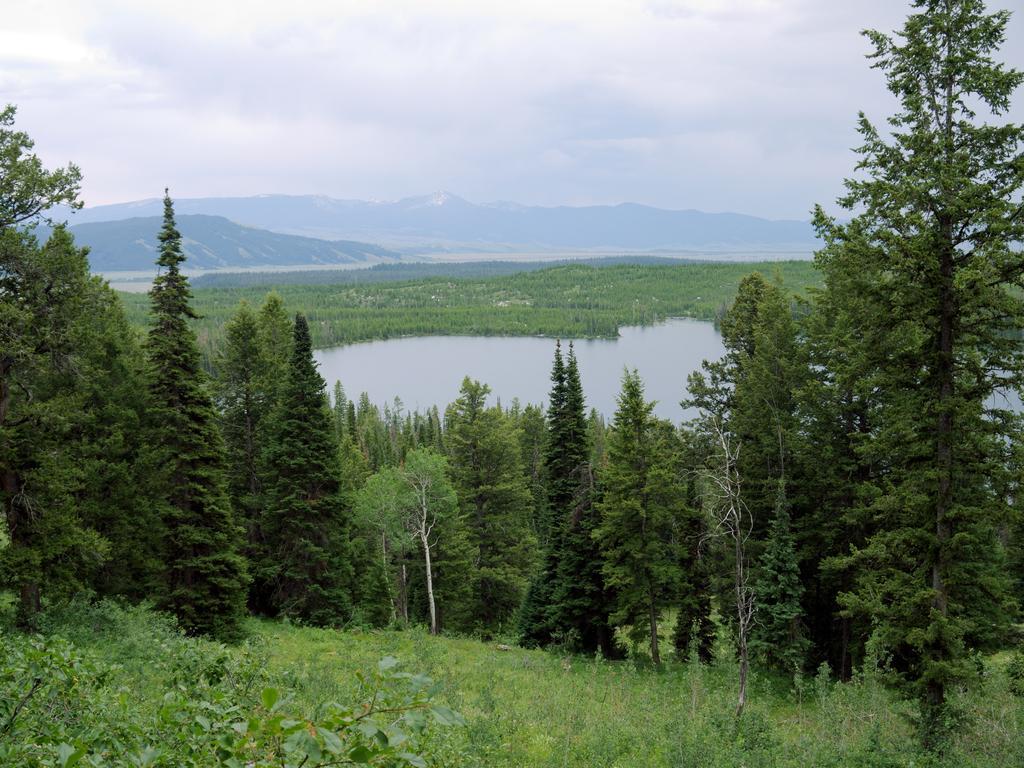In one or two sentences, can you explain what this image depicts? In this image I can see many trees and the water. In the background I can see the mountains, clouds and the sky. 